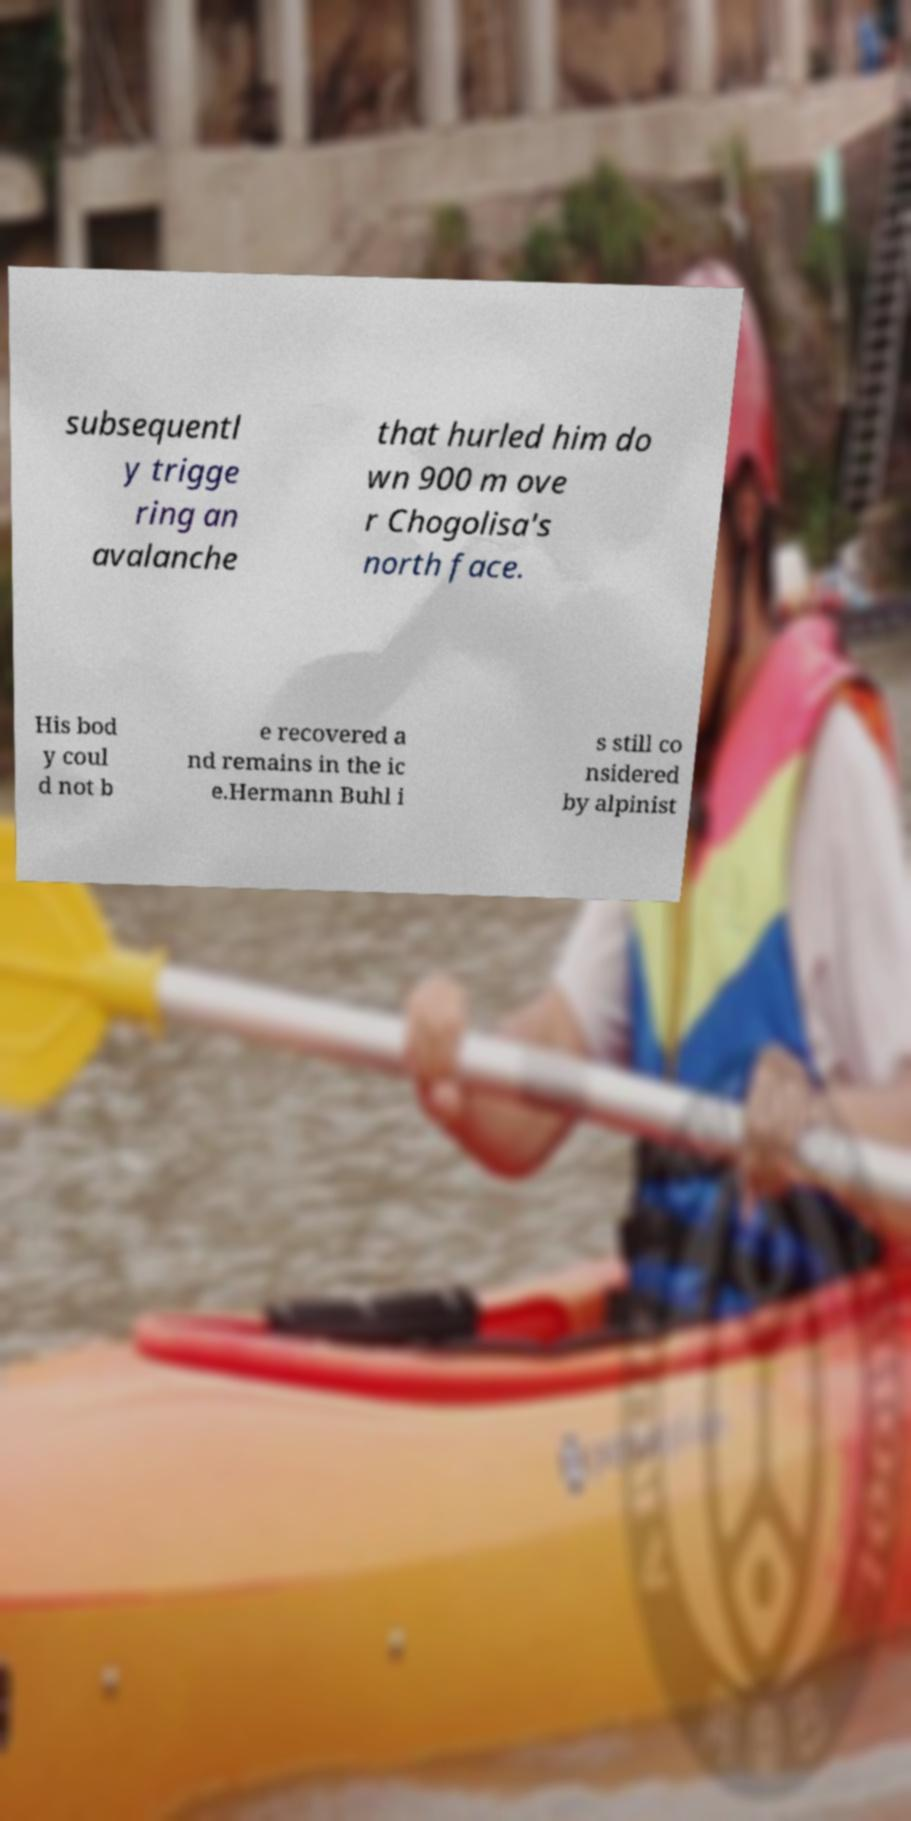There's text embedded in this image that I need extracted. Can you transcribe it verbatim? subsequentl y trigge ring an avalanche that hurled him do wn 900 m ove r Chogolisa's north face. His bod y coul d not b e recovered a nd remains in the ic e.Hermann Buhl i s still co nsidered by alpinist 